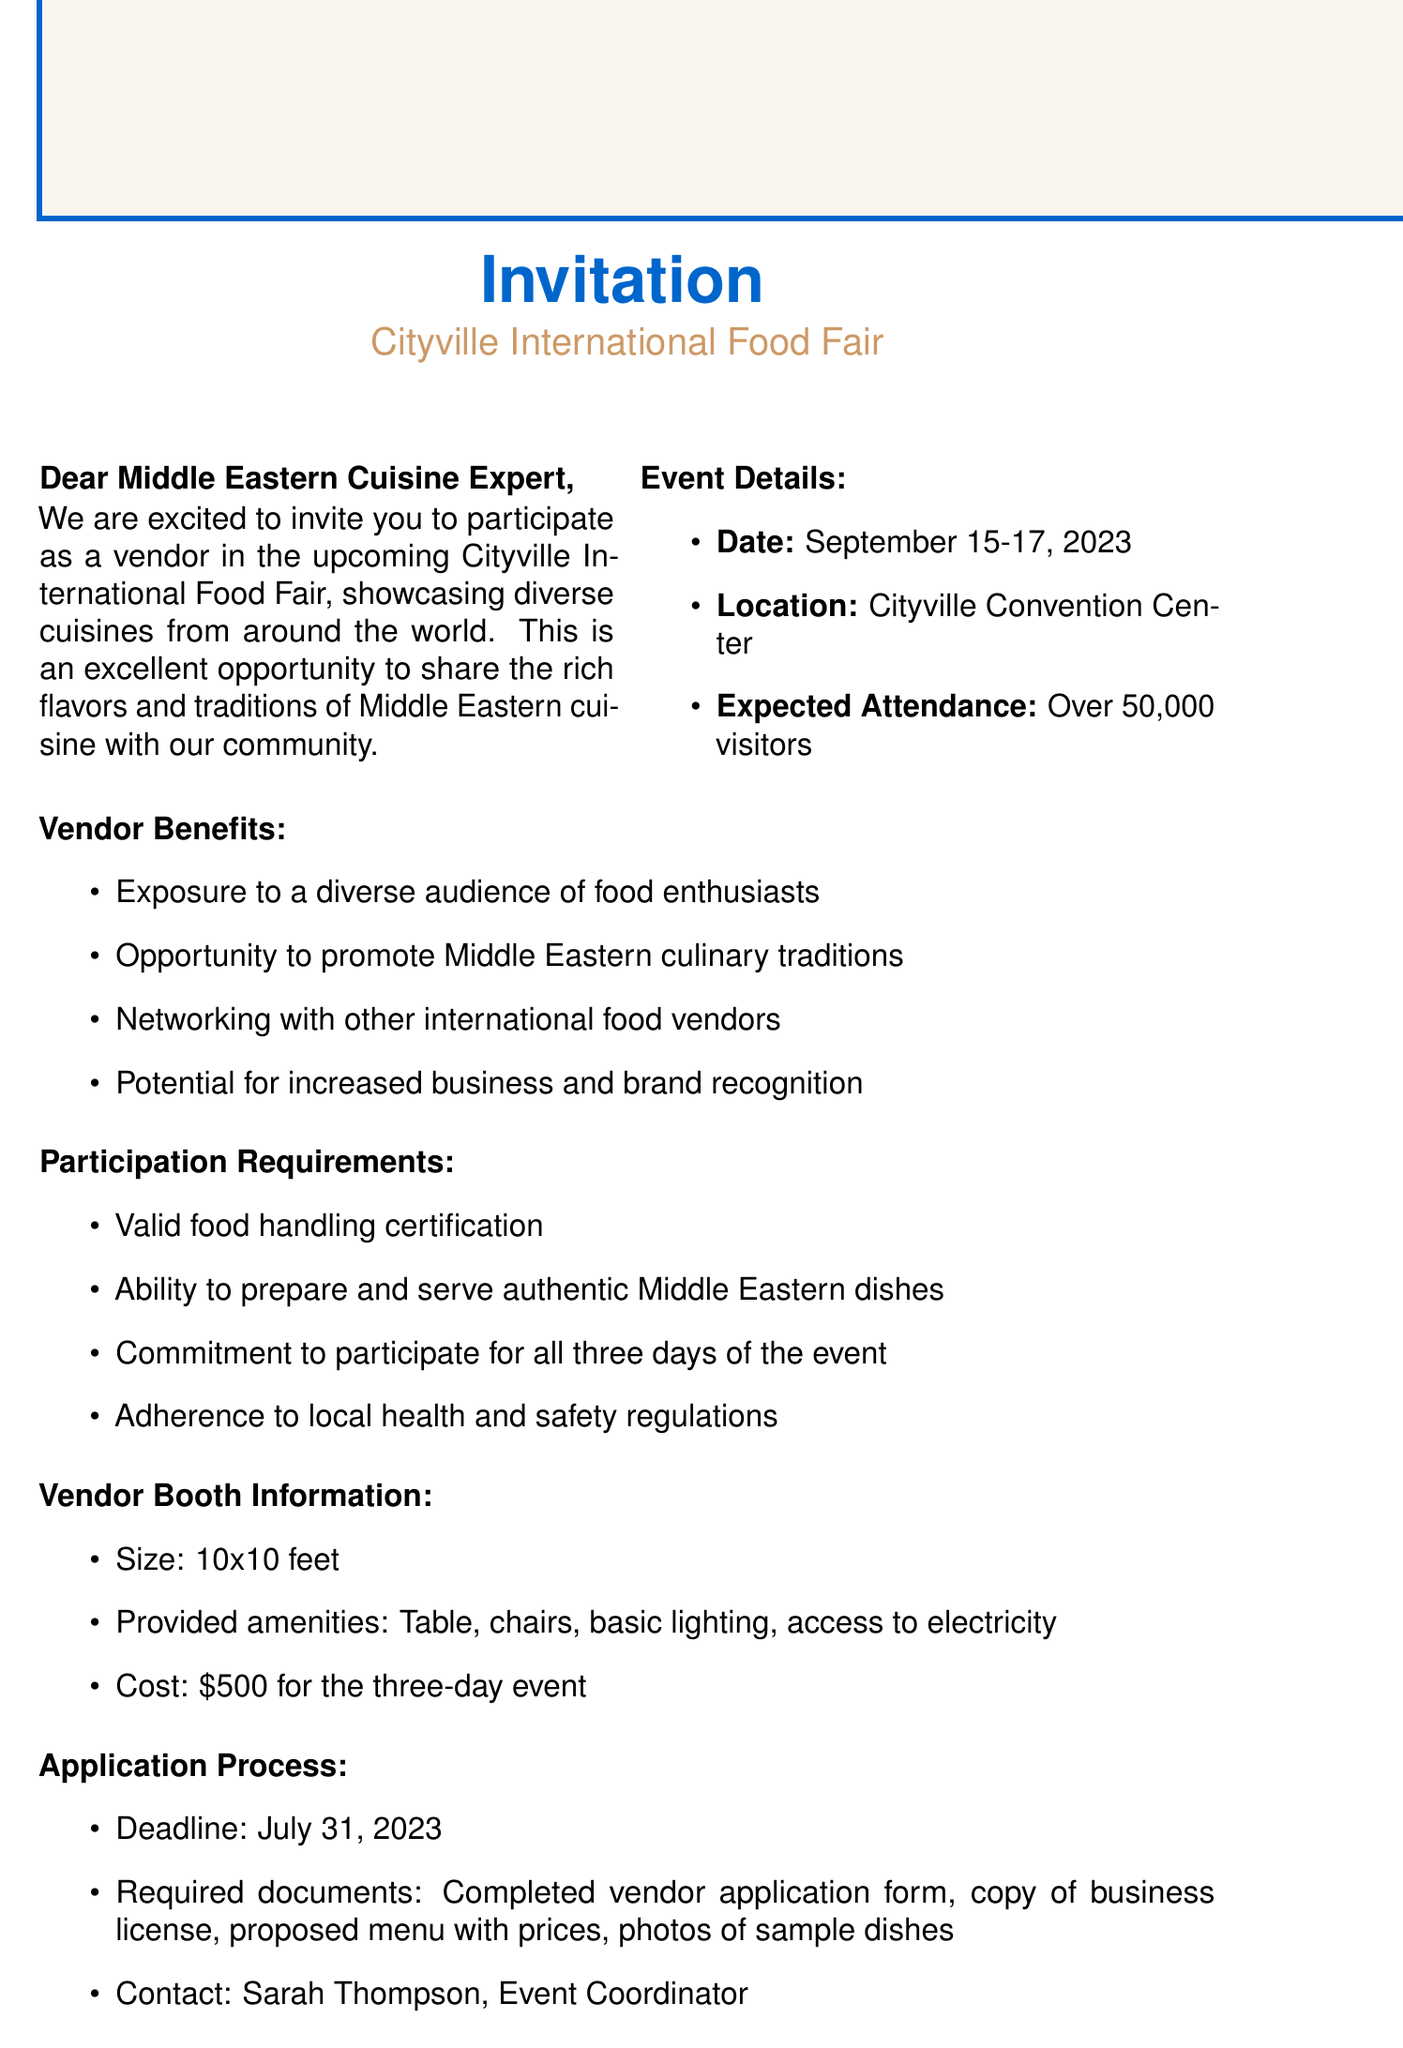What is the date of the event? The date of the event is stated in the document as September 15-17, 2023.
Answer: September 15-17, 2023 How much does it cost for a vendor booth? The cost for a vendor booth is specified in the document as $500 for the three-day event.
Answer: $500 What is the expected attendance? The document mentions that the expected attendance is over 50,000 visitors.
Answer: Over 50,000 visitors What are the provided amenities for the vendor booth? Amenities provided for the vendor booth are listed in the document, including a table, chairs, basic lighting, and access to electricity.
Answer: Table, chairs, basic lighting, access to electricity Who is the contact person for the event? The contact person is named in the document as Sarah Thompson, Event Coordinator.
Answer: Sarah Thompson What is the deadline for application submission? The document states that the deadline for application submission is July 31, 2023.
Answer: July 31, 2023 What kind of cuisine is the focus of the event? The event focuses on showcasing diverse cuisines, specifically highlighting Middle Eastern cuisine in this invitation.
Answer: Middle Eastern cuisine What is one benefit of participating in the event? The document emphasizes benefits such as exposure to a diverse audience of food enthusiasts as a reason to participate.
Answer: Exposure to a diverse audience of food enthusiasts What is required for food handling participation? A valid food handling certification is required as per the participation requirements noted in the document.
Answer: Valid food handling certification 